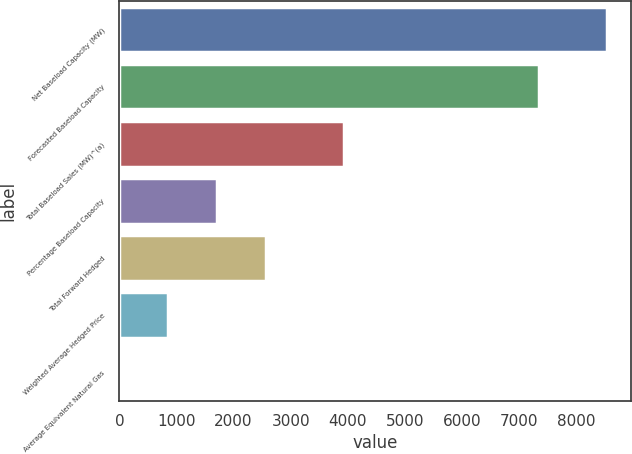Convert chart. <chart><loc_0><loc_0><loc_500><loc_500><bar_chart><fcel>Net Baseload Capacity (MW)<fcel>Forecasted Baseload Capacity<fcel>Total Baseload Sales (MW)^(a)<fcel>Percentage Baseload Capacity<fcel>Total Forward Hedged<fcel>Weighted Average Hedged Price<fcel>Average Equivalent Natural Gas<nl><fcel>8528<fcel>7350<fcel>3938<fcel>1711.1<fcel>2563.21<fcel>858.99<fcel>6.88<nl></chart> 